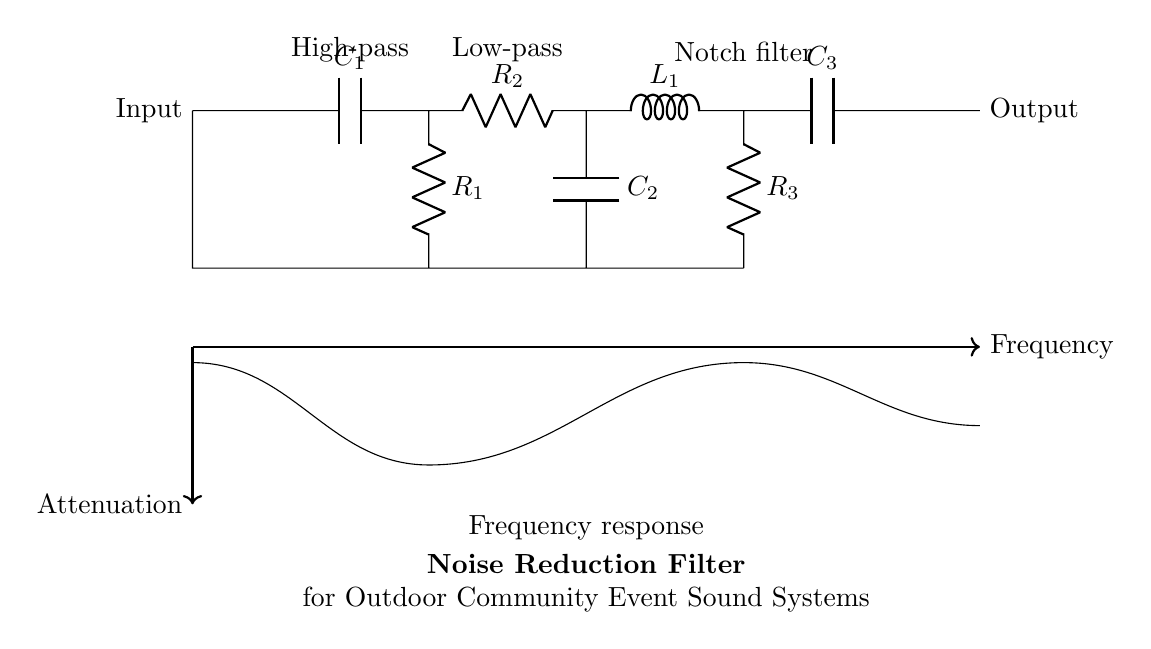What type of filter is this circuit? The circuit implements a noise reduction filter consisting of high-pass, low-pass, and notch components. Each section serves a specific purpose in filtering out unwanted frequencies.
Answer: Noise reduction filter What are the components used in the high-pass section? The high-pass filter includes a capacitor labeled C1 and a resistor labeled R1. The capacitor allows high frequencies to pass while blocking low frequencies, and the resistor affects the cutoff frequency.
Answer: C1, R1 Which filter component is responsible for reducing low frequencies? The low-pass filter uses a resistor labeled R2 followed by a capacitor labeled C2 to allow low frequencies to pass and attenuate higher frequencies.
Answer: R2, C2 What is the main feature of the notch filter in this circuit? The notch filter, consisting of an inductor L1 and a capacitor C3 along with a resistor R3, is designed to attenuate a specific range of frequencies, providing selective frequency reduction.
Answer: Selective frequency reduction How many filters are combined in this circuit? The circuit integrates three different types of filters: a high-pass filter, a low-pass filter, and a notch filter, which work together to enhance sound quality by minimizing noise.
Answer: Three filters 